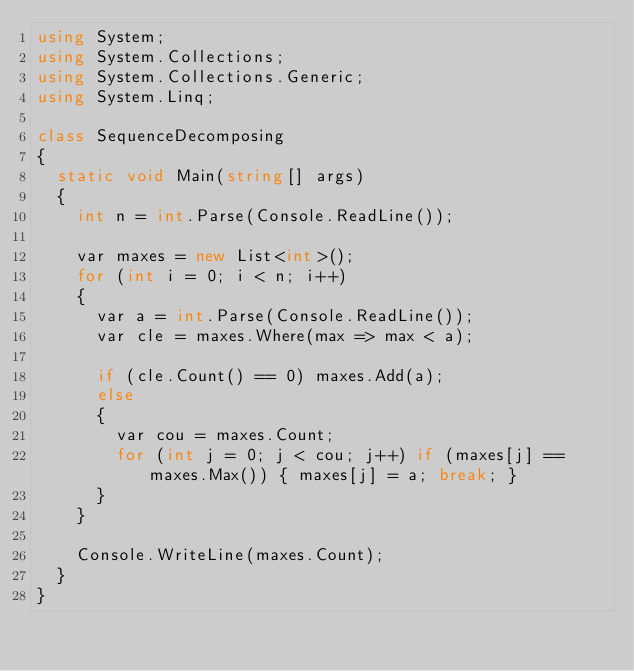<code> <loc_0><loc_0><loc_500><loc_500><_C#_>using System;
using System.Collections;
using System.Collections.Generic;
using System.Linq;

class SequenceDecomposing
{
  static void Main(string[] args)
  {
    int n = int.Parse(Console.ReadLine());
    
    var maxes = new List<int>();
    for (int i = 0; i < n; i++)
    {
      var a = int.Parse(Console.ReadLine());
      var cle = maxes.Where(max => max < a);
      
      if (cle.Count() == 0) maxes.Add(a);
      else
      {
        var cou = maxes.Count;
        for (int j = 0; j < cou; j++) if (maxes[j] == maxes.Max()) { maxes[j] = a; break; }
      }
    }
    
    Console.WriteLine(maxes.Count);
  }
}</code> 